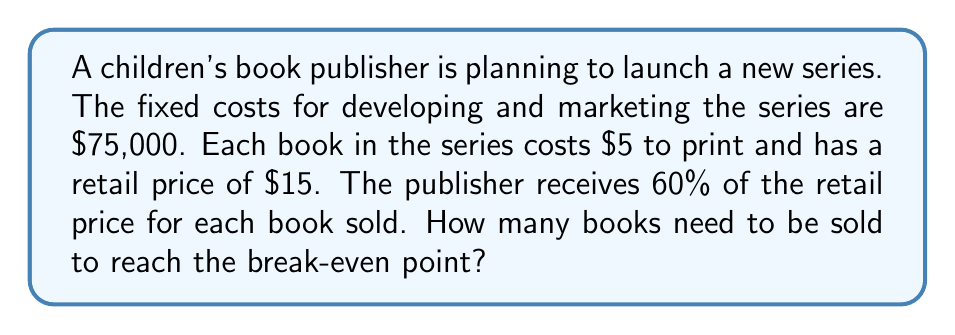Could you help me with this problem? To calculate the break-even point, we need to determine the number of books that need to be sold for the revenue to equal the total costs. Let's break this down step-by-step:

1. Define variables:
   Let $x$ = number of books sold
   
2. Calculate revenue per book:
   Retail price = $15
   Publisher's share = 60% = 0.60
   Revenue per book = $15 * 0.60 = $9

3. Calculate variable cost per book:
   Printing cost per book = $5

4. Calculate contribution margin per book:
   Contribution margin = Revenue per book - Variable cost per book
   $9 - $5 = $4

5. Set up the break-even equation:
   Total Revenue = Total Costs
   $9x = 75000 + 5x$

6. Solve for x:
   $9x - 5x = 75000$
   $4x = 75000$
   $x = \frac{75000}{4} = 18750$

Therefore, the publisher needs to sell 18,750 books to reach the break-even point.

To verify:
Revenue: $18750 * $9 = $168,750
Costs: $75,000 + (18750 * $5) = $168,750

Revenue equals costs, confirming the break-even point.
Answer: 18,750 books 